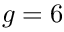Convert formula to latex. <formula><loc_0><loc_0><loc_500><loc_500>g = 6</formula> 